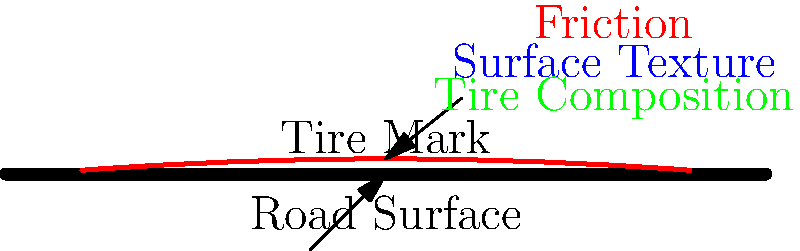In a racing game, you need to implement a system for rendering realistic tire marks on various road surfaces. Which of the following factors would be least important to consider when calculating the appearance and intensity of tire marks?

A) Tire composition
B) Vehicle speed
C) Road surface texture
D) Ambient temperature
E) Applied braking force To determine the least important factor for rendering realistic tire marks, let's consider each option:

1. Tire composition: This is crucial as different tire compounds leave different marks. Softer compounds generally leave more prominent marks.

2. Vehicle speed: Higher speeds typically result in more intense tire marks, especially during sudden braking or cornering.

3. Road surface texture: The texture of the road significantly affects how tire marks appear. Rough surfaces may show less distinct marks compared to smooth surfaces.

4. Ambient temperature: While temperature can affect tire behavior in real life, it has a minimal impact on the visual appearance of tire marks in a racing game context.

5. Applied braking force: This is a critical factor as stronger braking forces lead to more intense and visible tire marks.

Analyzing these factors:

- Tire composition, vehicle speed, road surface texture, and applied braking force all have direct and significant impacts on the appearance and intensity of tire marks.
- Ambient temperature, while it can affect tire performance in reality, has a minimal visual impact on tire marks compared to the other factors.

Therefore, the least important factor to consider when calculating the appearance and intensity of tire marks in a racing game would be ambient temperature.
Answer: D) Ambient temperature 